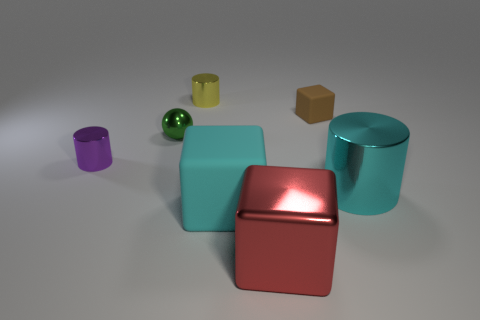Do the green sphere and the purple metal object have the same size?
Ensure brevity in your answer.  Yes. How many objects are big rubber things or large purple balls?
Your response must be concise. 1. The matte object in front of the tiny purple cylinder that is in front of the rubber object right of the large red metal block is what shape?
Provide a succinct answer. Cube. Are the cylinder to the left of the yellow metallic cylinder and the cylinder that is behind the ball made of the same material?
Make the answer very short. Yes. What is the material of the big cyan thing that is the same shape as the purple object?
Provide a short and direct response. Metal. Is there anything else that has the same size as the red block?
Your response must be concise. Yes. There is a object behind the brown matte object; is it the same shape as the large object to the right of the tiny brown thing?
Your answer should be compact. Yes. Are there fewer tiny purple metal cylinders that are to the right of the large red object than large cylinders left of the small brown rubber cube?
Make the answer very short. No. What number of other objects are there of the same shape as the tiny purple object?
Give a very brief answer. 2. There is a big cyan object that is made of the same material as the tiny green ball; what shape is it?
Keep it short and to the point. Cylinder. 